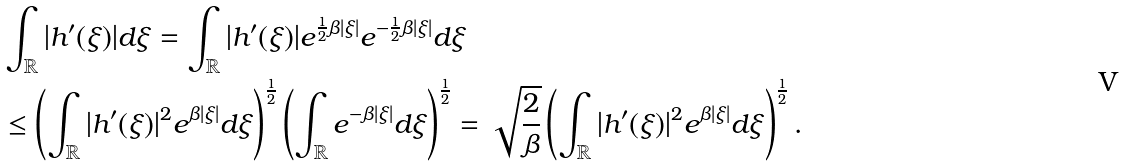<formula> <loc_0><loc_0><loc_500><loc_500>& \int _ { \mathbb { R } } | h ^ { \prime } ( \xi ) | d \xi = \int _ { \mathbb { R } } | h ^ { \prime } ( \xi ) | e ^ { \frac { 1 } { 2 } \beta | \xi | } e ^ { - \frac { 1 } { 2 } \beta | \xi | } d \xi \\ & \leq \left ( \int _ { \mathbb { R } } | h ^ { \prime } ( \xi ) | ^ { 2 } e ^ { \beta | \xi | } d \xi \right ) ^ { \frac { 1 } { 2 } } \left ( \int _ { \mathbb { R } } e ^ { - \beta | \xi | } d \xi \right ) ^ { \frac { 1 } { 2 } } = \sqrt { \frac { 2 } { \beta } } \left ( \int _ { \mathbb { R } } | h ^ { \prime } ( \xi ) | ^ { 2 } e ^ { \beta | \xi | } d \xi \right ) ^ { \frac { 1 } { 2 } } .</formula> 